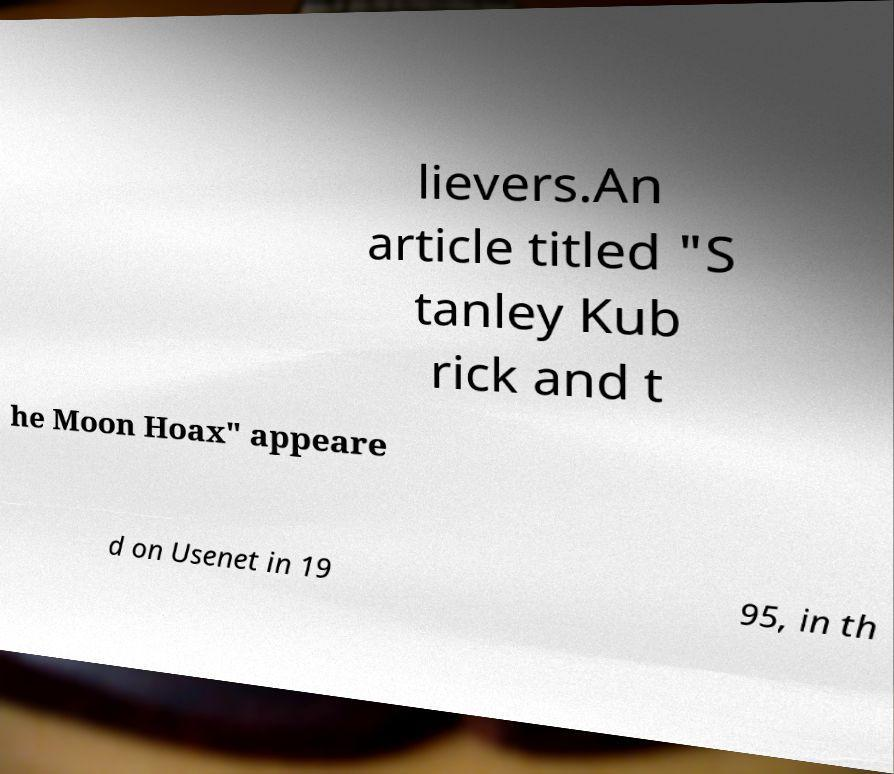Could you assist in decoding the text presented in this image and type it out clearly? lievers.An article titled "S tanley Kub rick and t he Moon Hoax" appeare d on Usenet in 19 95, in th 